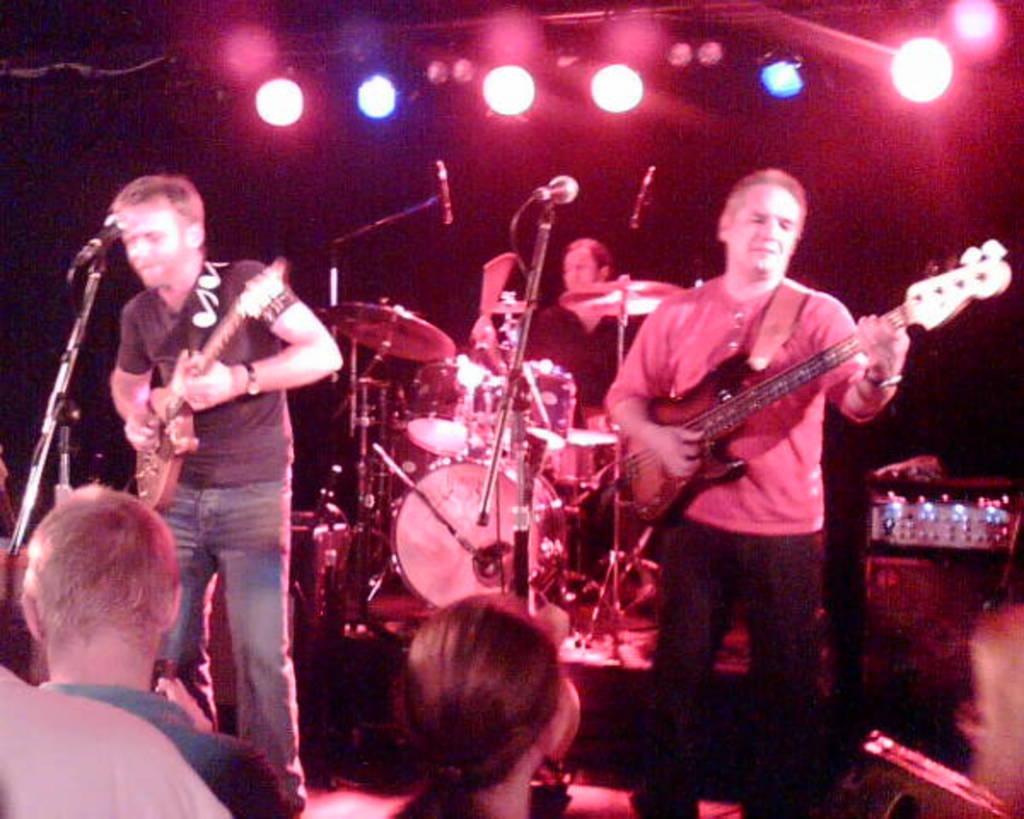Can you describe this image briefly? This is the picture of three people playing some different musical instruments and some people in front of them and there are some lines above them. 